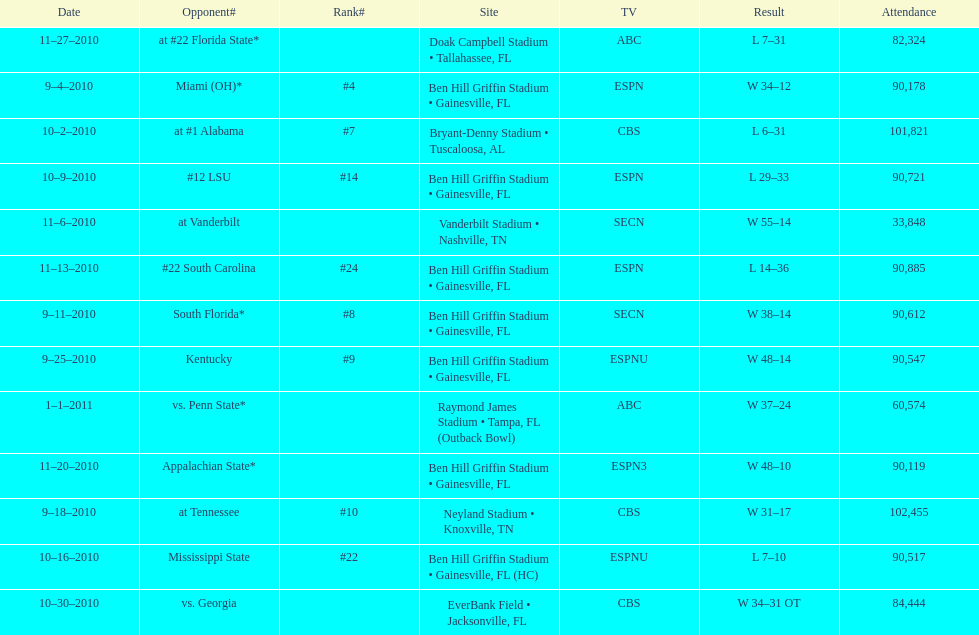What was the discrepancy between the two scores of the previous game? 13 points. 